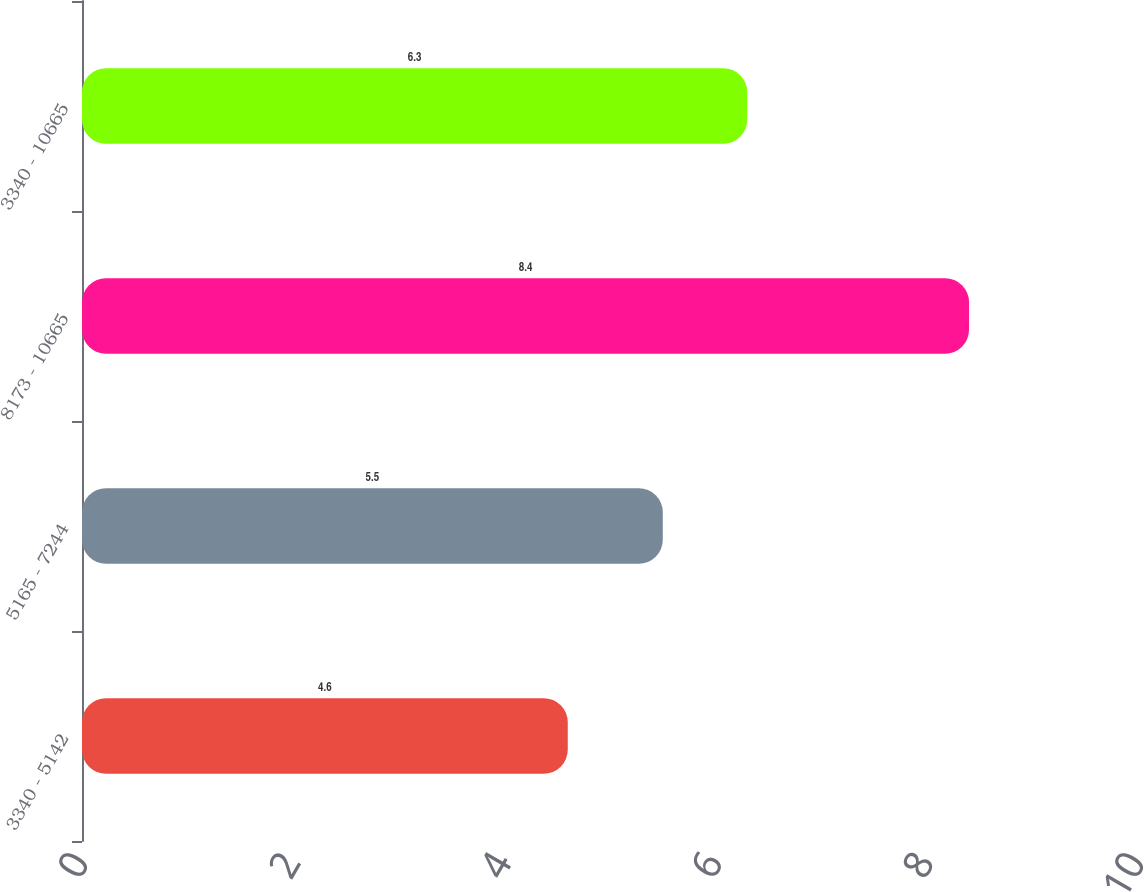Convert chart. <chart><loc_0><loc_0><loc_500><loc_500><bar_chart><fcel>3340 - 5142<fcel>5165 - 7244<fcel>8173 - 10665<fcel>3340 - 10665<nl><fcel>4.6<fcel>5.5<fcel>8.4<fcel>6.3<nl></chart> 